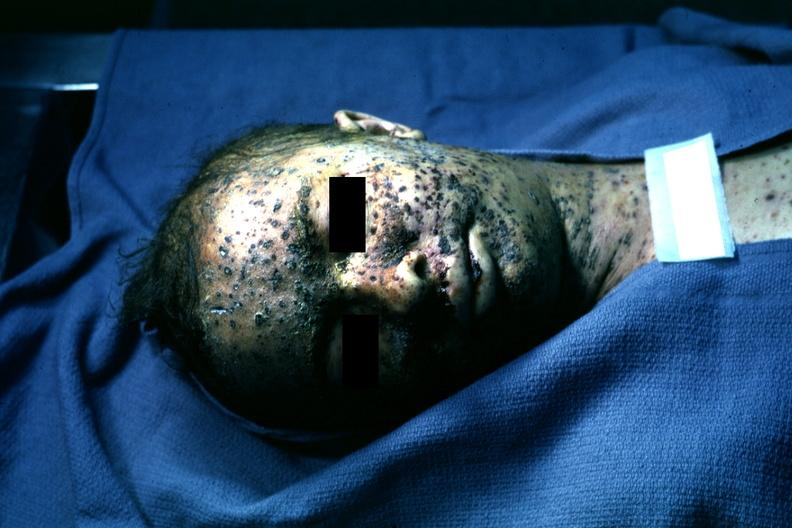s herpes zoster present?
Answer the question using a single word or phrase. Yes 